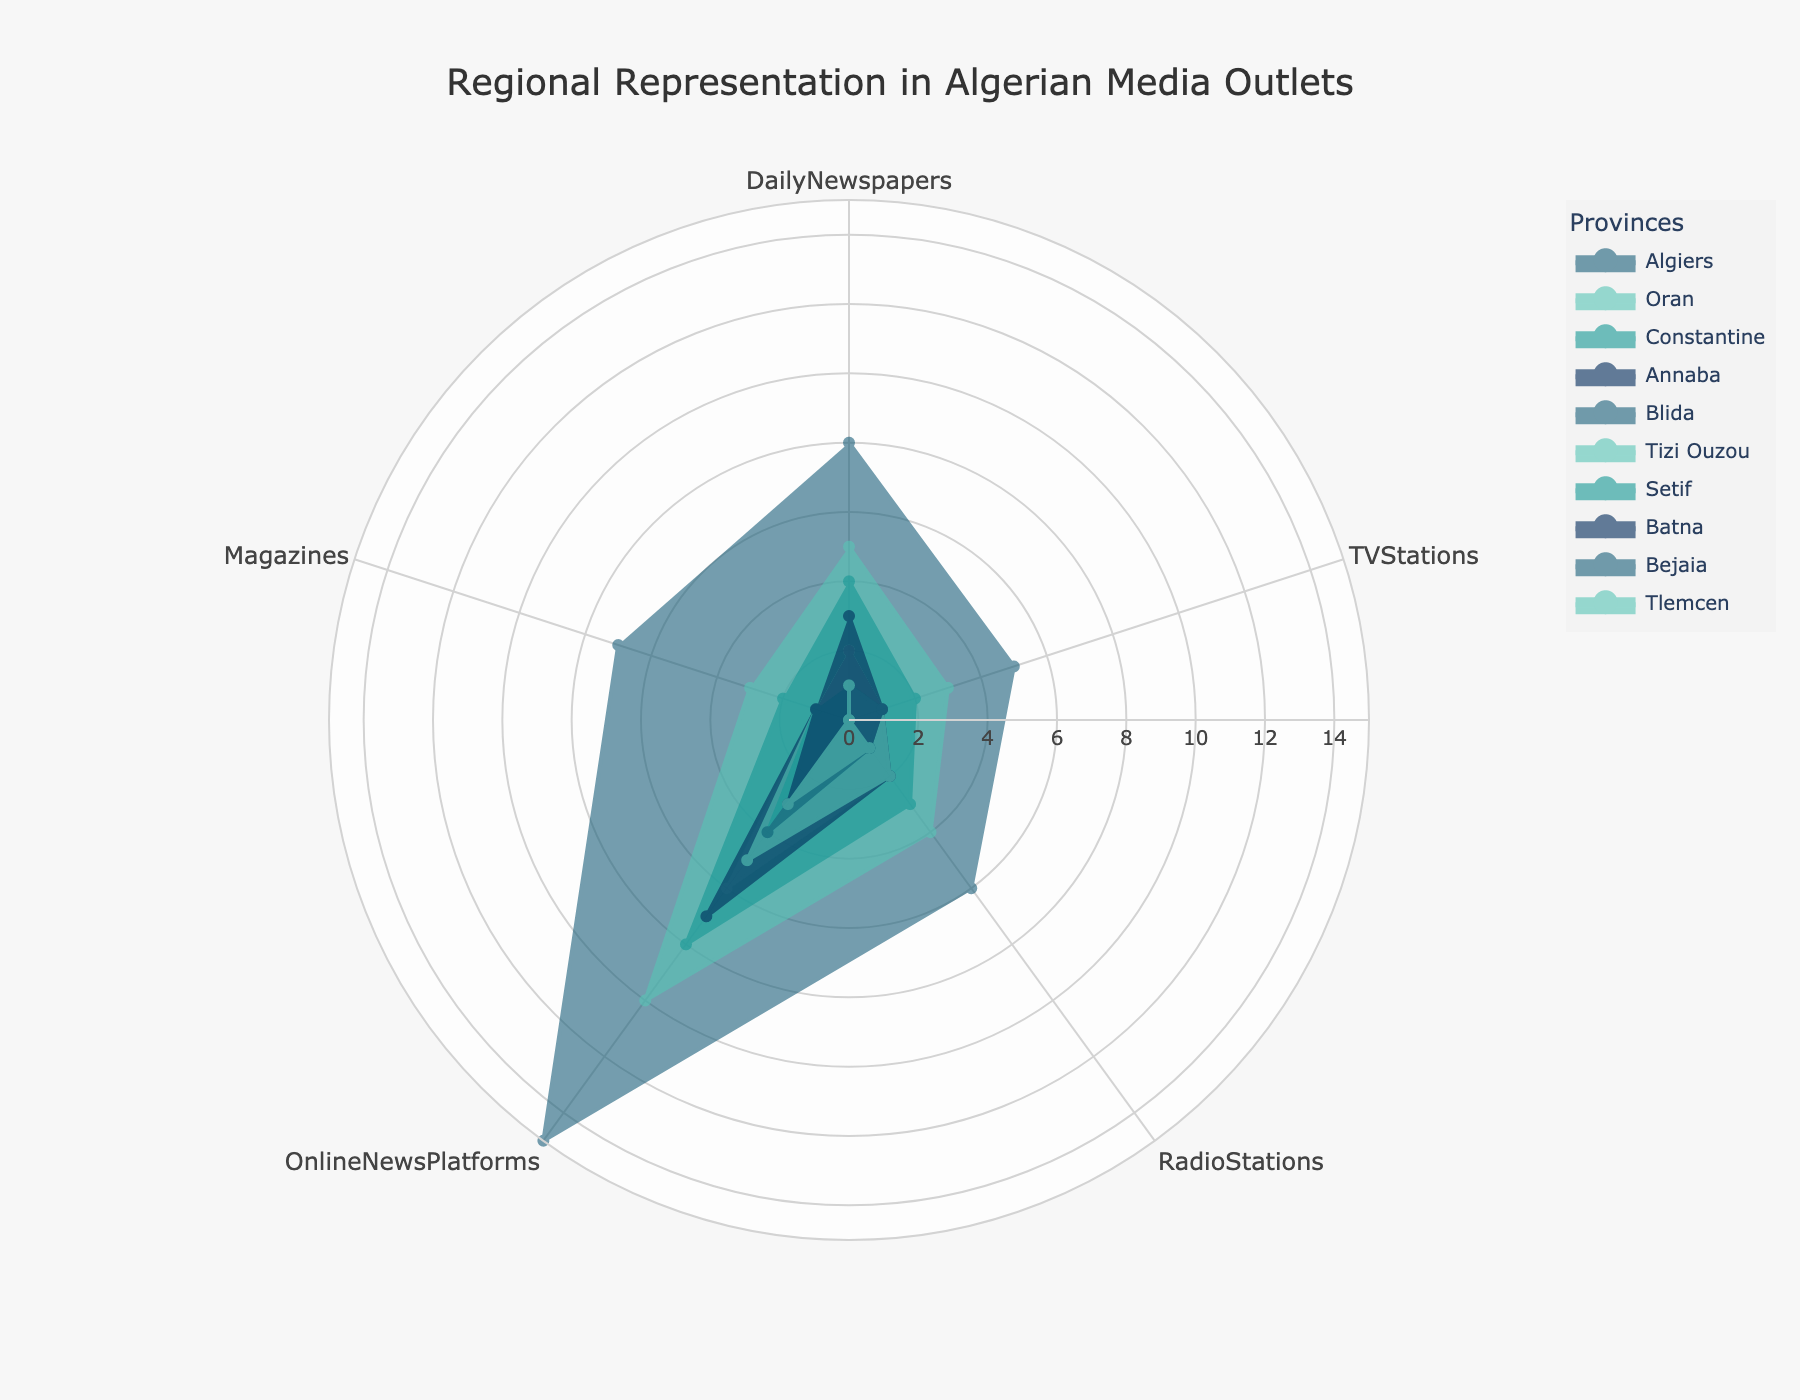Which province has the most diverse media representation across all categories? By observing the figure, Algiers has the highest values across most media categories including Daily Newspapers, TV Stations, Radio Stations, Online News Platforms, and Magazines, indicating the most diverse representation.
Answer: Algiers Which province has the least representation in TV Stations? Through visual comparison, Tlemcen has no representation in TV Stations, which is the least among all provinces.
Answer: Tlemcen What's the difference in the number of Daily Newspapers between Algiers and Constantine? Algiers has 8 Daily Newspapers, and Constantine has 4. The difference is 8 - 4 = 4.
Answer: 4 How many provinces have fewer than 2 Magazines? From the visual information, Annaba, Blida, Tizi Ouzou, Setif, Batna, Bejaia, and Tlemcen have fewer than 2 Magazines, amounting to 7 provinces.
Answer: 7 Compare the number of Online News Platforms in Oran and Annaba. Which one has more, and by how much? Oran has 10 Online News Platforms and Annaba has 7. Oran has 10 - 7 = 3 more Online News Platforms than Annaba.
Answer: Oran by 3 What is the total number of Radio Stations in the three provinces with the least representation? The three provinces with the least Radio Stations are Setif, Batna, and Tlemcen. Each has 1 Radio Station. The total is 1 + 1 + 1 = 3.
Answer: 3 Which category has the highest average value across all provinces? To find the average value for each category, sum the values across all provinces and divide by the number of provinces. Online News Platforms have the highest sum and average value, indicating it's more prevalent.
Answer: Online News Platforms What is the ratio of TV Stations between Algiers and Oran? Algiers has 5 TV Stations, and Oran has 3. The ratio of TV Stations between Algiers and Oran is 5:3.
Answer: 5:3 What is the total count of media outlets in Constantine? Summing all categories in Constantine: 4 (Daily Newspapers) + 2 (TV Stations) + 3 (Radio Stations) + 8 (Online News Platforms) + 2 (Magazines) = 19.
Answer: 19 Which category shows the most equal representation across different provinces? By visually comparing the lengths of the radial axes across different categories, Magazines have values that are most uniformly distributed across provinces.
Answer: Magazines 